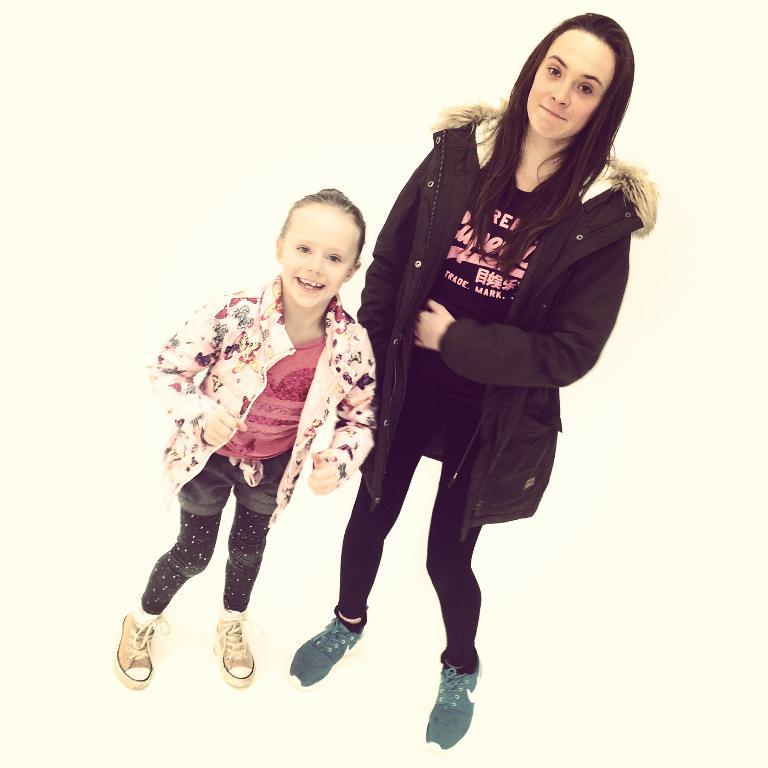Who is present in the image? There is a girl and a woman in the image. What are the expressions on their faces? Both the girl and the woman are smiling. What are they standing on in the image? They are both standing on a surface. What is the color of the background in the image? The background of the image is cream in color. What type of twig is the girl holding in the image? There is no twig present in the image. What reason does the woman have for smiling in the image? The image does not provide any information about the reason for the woman's smile. 